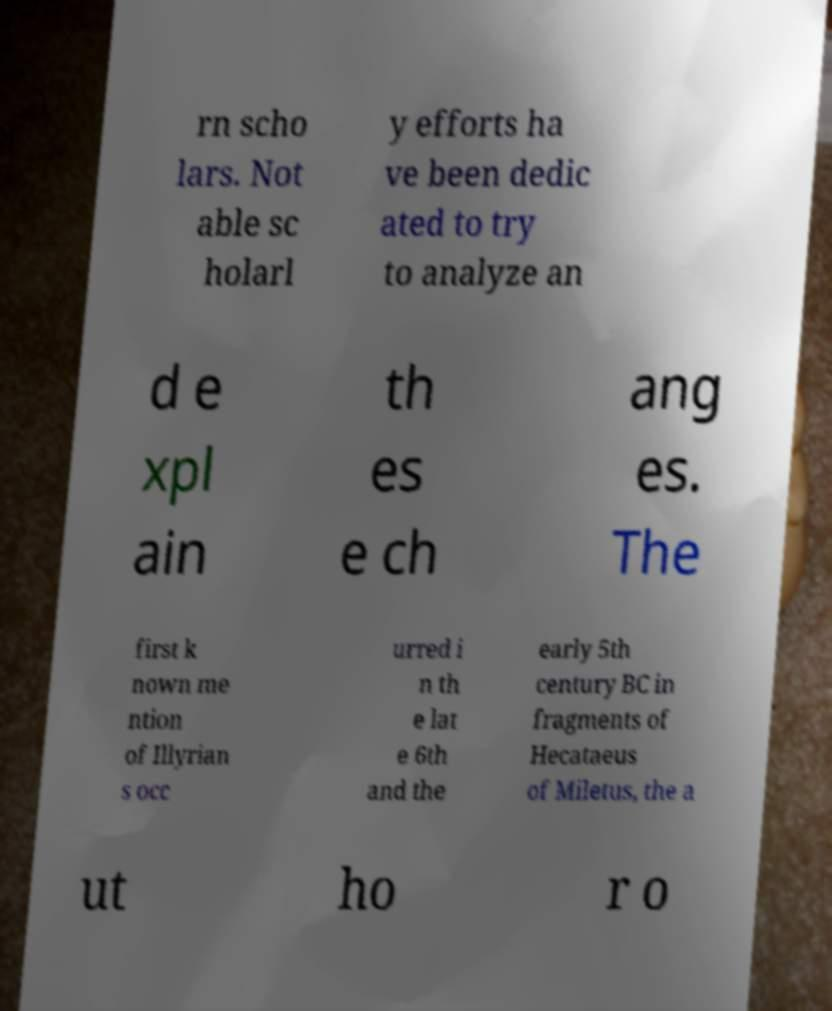Please identify and transcribe the text found in this image. rn scho lars. Not able sc holarl y efforts ha ve been dedic ated to try to analyze an d e xpl ain th es e ch ang es. The first k nown me ntion of Illyrian s occ urred i n th e lat e 6th and the early 5th century BC in fragments of Hecataeus of Miletus, the a ut ho r o 